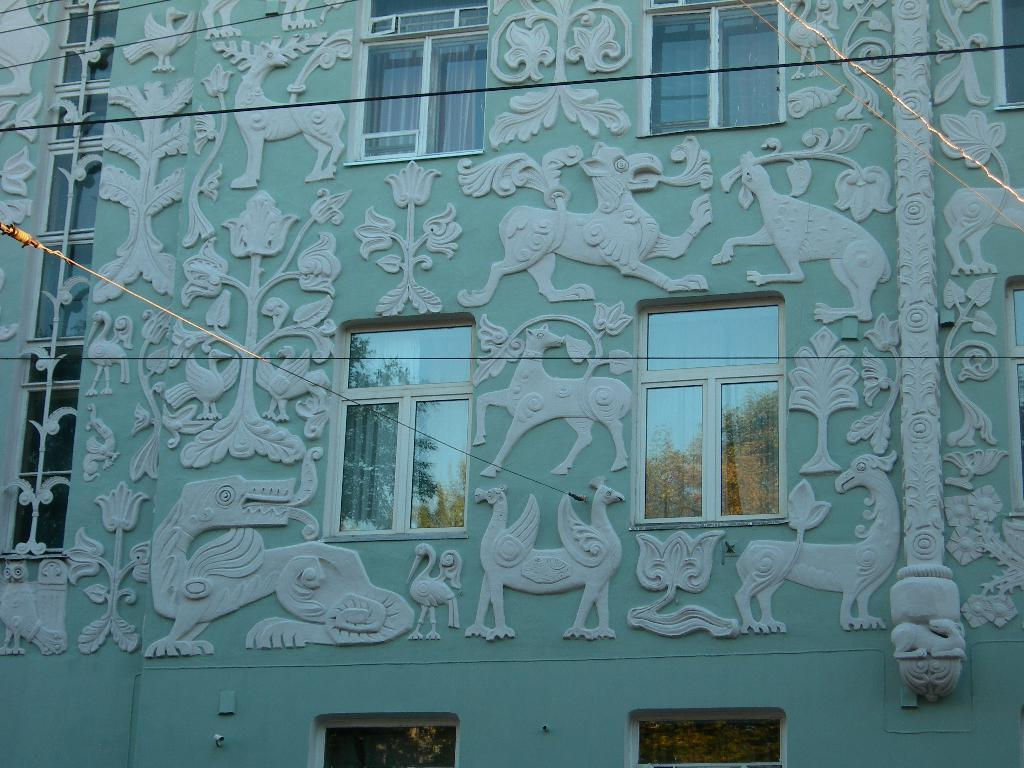What type of structure is present in the image? There is a building in the image. What feature can be seen on the building? The building has windows. Is there any decoration or design on the building? Yes, there is some art on the building. What else can be seen in the image besides the building? There are wires visible in the image. Can you see any toes sticking out of the building in the image? No, there are no toes visible in the image. 